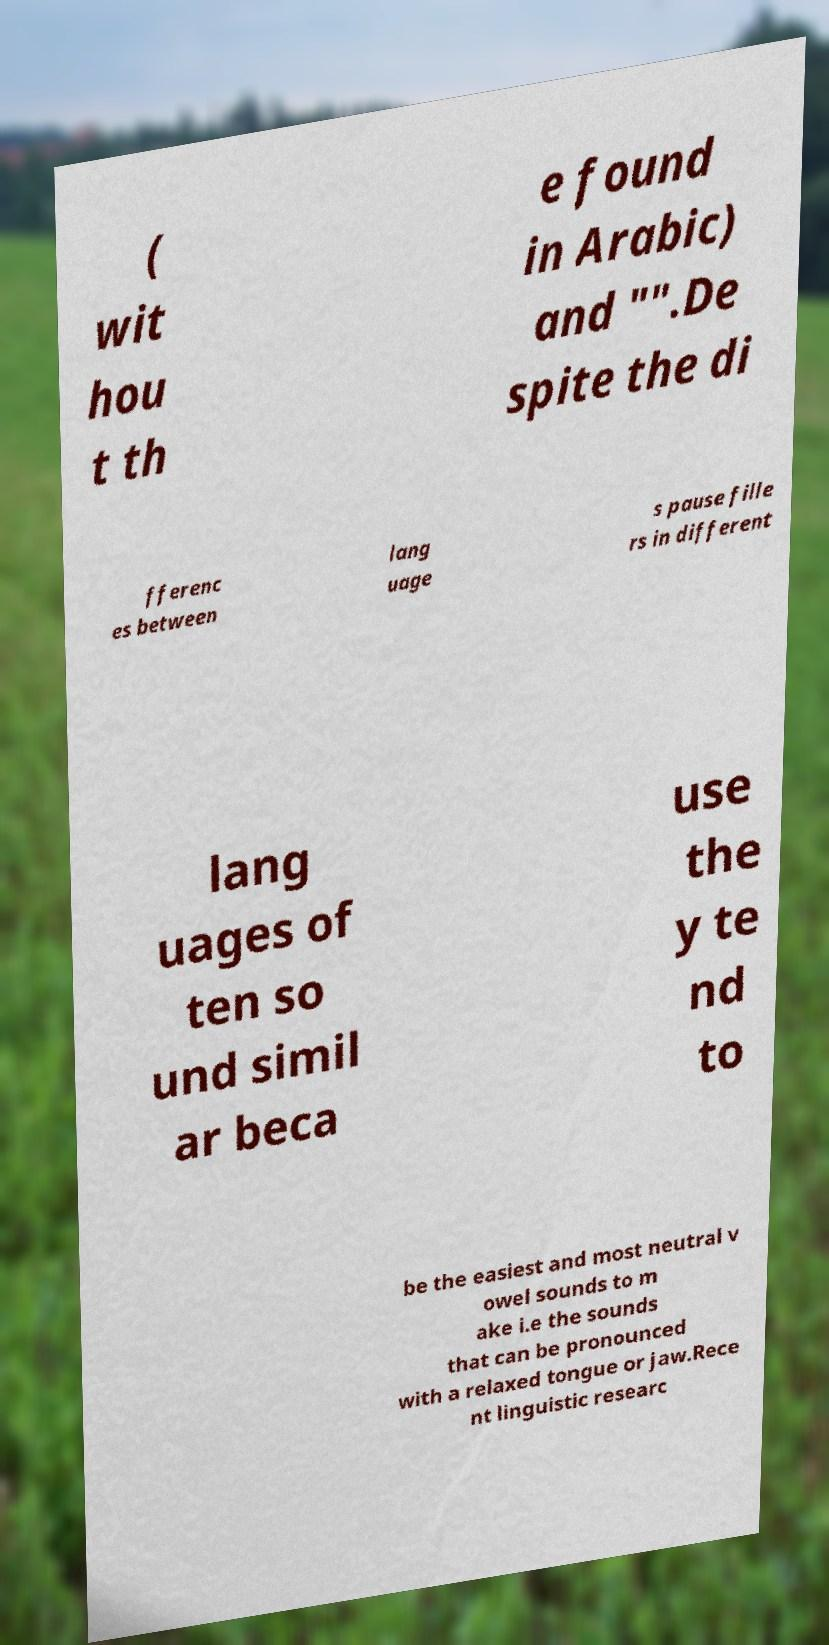Can you accurately transcribe the text from the provided image for me? ( wit hou t th e found in Arabic) and "".De spite the di fferenc es between lang uage s pause fille rs in different lang uages of ten so und simil ar beca use the y te nd to be the easiest and most neutral v owel sounds to m ake i.e the sounds that can be pronounced with a relaxed tongue or jaw.Rece nt linguistic researc 